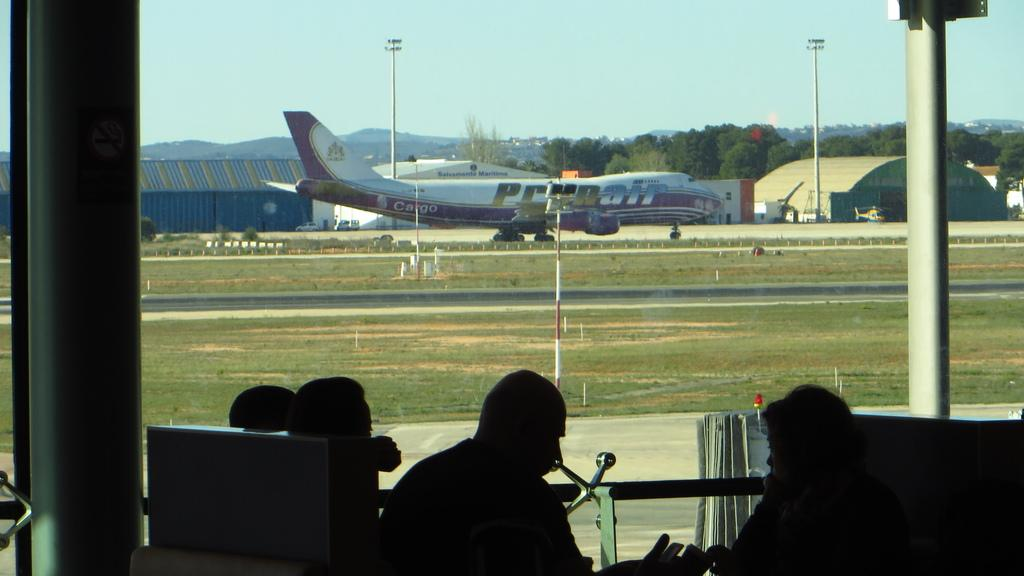<image>
Relay a brief, clear account of the picture shown. A Prunair passenger plane pulling into a runway. 